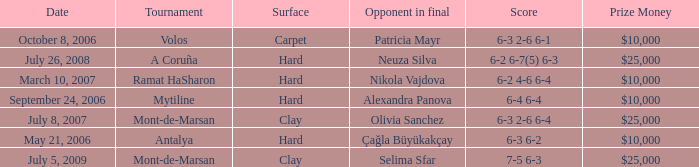What is the surface of the match on July 5, 2009? Clay. 